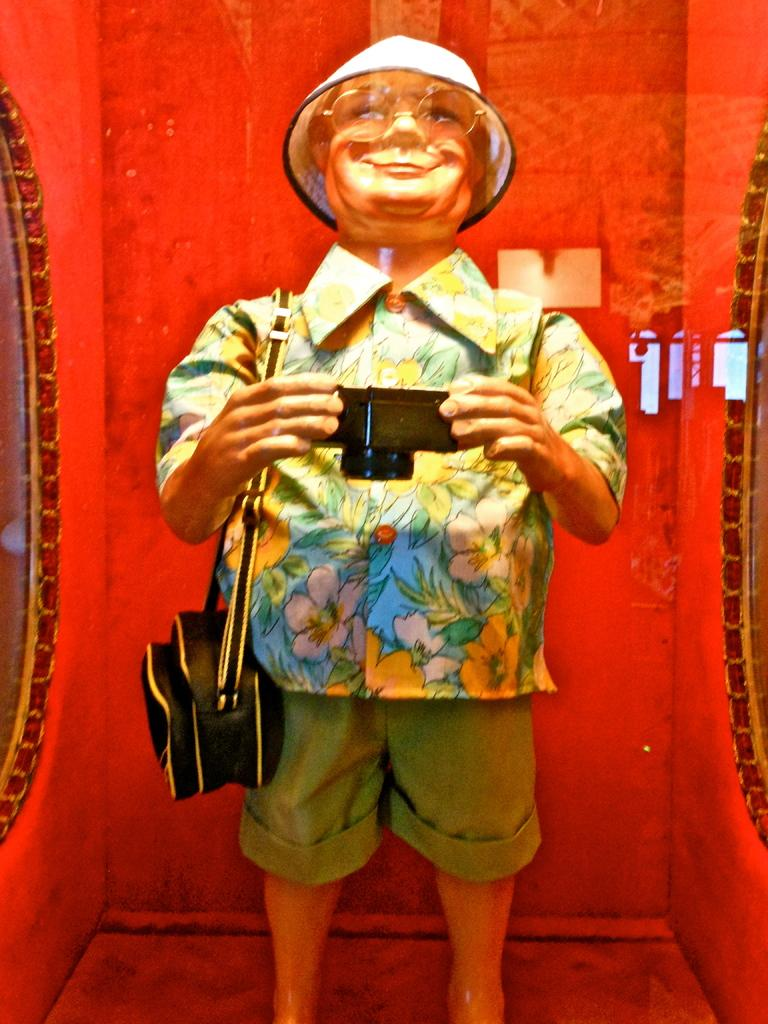What is the main subject of the image? There is a sculpture in the image. What does the sculpture depict? The sculpture depicts a person. What is the person in the sculpture wearing? The person is wearing a hat. What is the person in the sculpture holding? The person is holding a camera and a bag. What type of clam is visible in the image? There is no clam present in the image; it features a sculpture of a person. What substance is being dropped by the person in the image? There is no substance being dropped by the person in the image; they are holding a camera and a bag. 